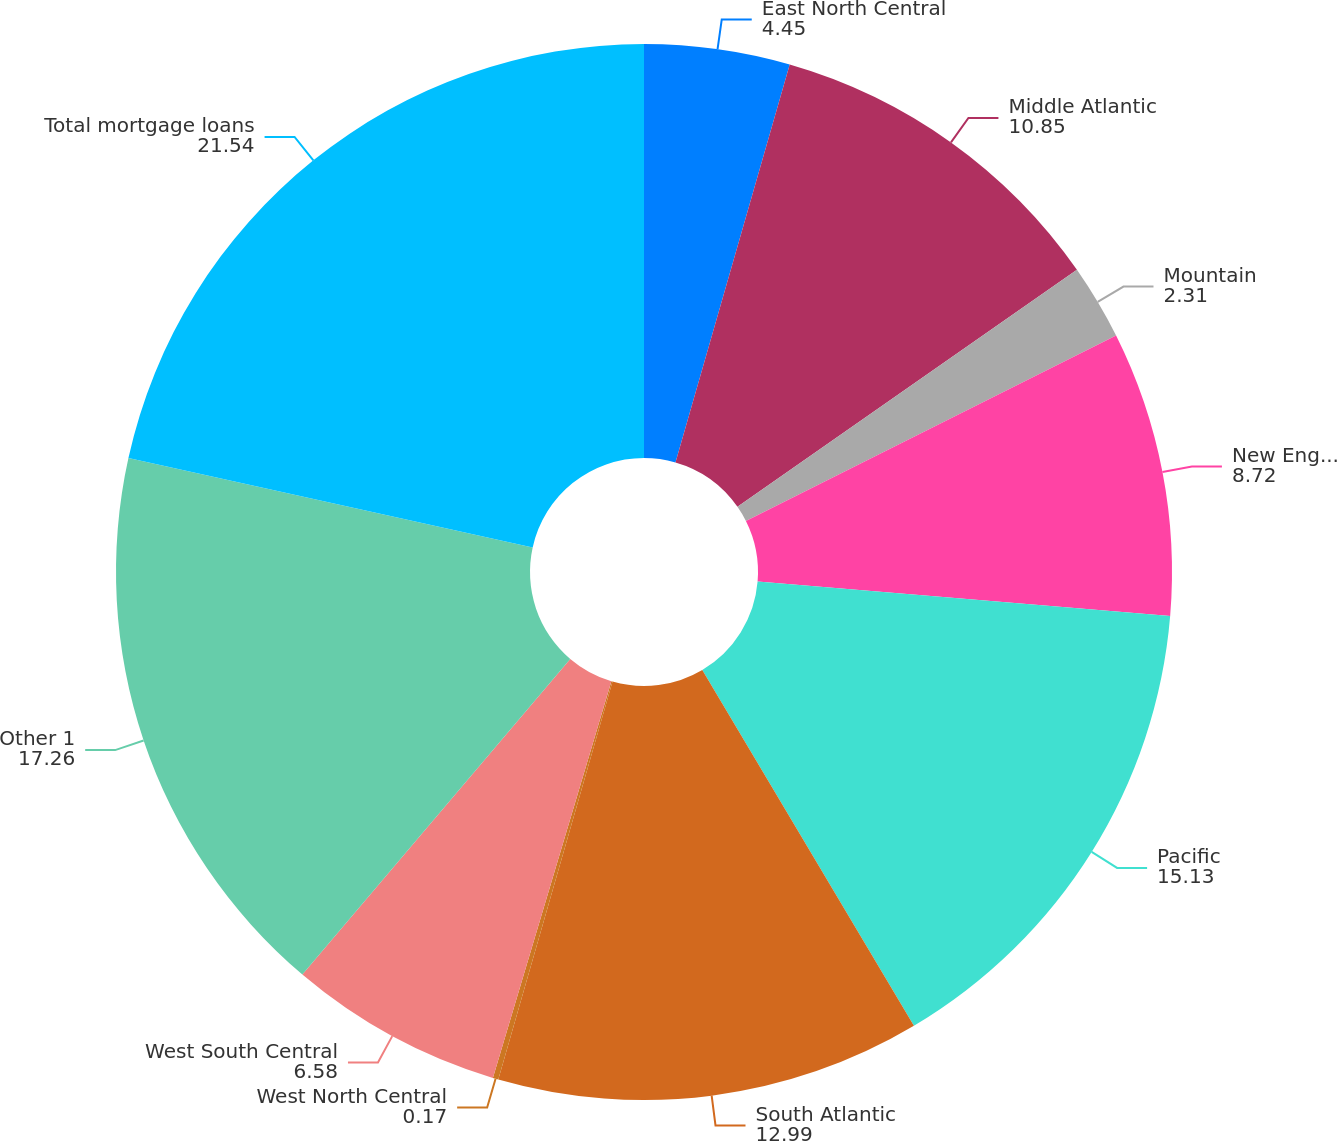<chart> <loc_0><loc_0><loc_500><loc_500><pie_chart><fcel>East North Central<fcel>Middle Atlantic<fcel>Mountain<fcel>New England<fcel>Pacific<fcel>South Atlantic<fcel>West North Central<fcel>West South Central<fcel>Other 1<fcel>Total mortgage loans<nl><fcel>4.45%<fcel>10.85%<fcel>2.31%<fcel>8.72%<fcel>15.13%<fcel>12.99%<fcel>0.17%<fcel>6.58%<fcel>17.26%<fcel>21.54%<nl></chart> 